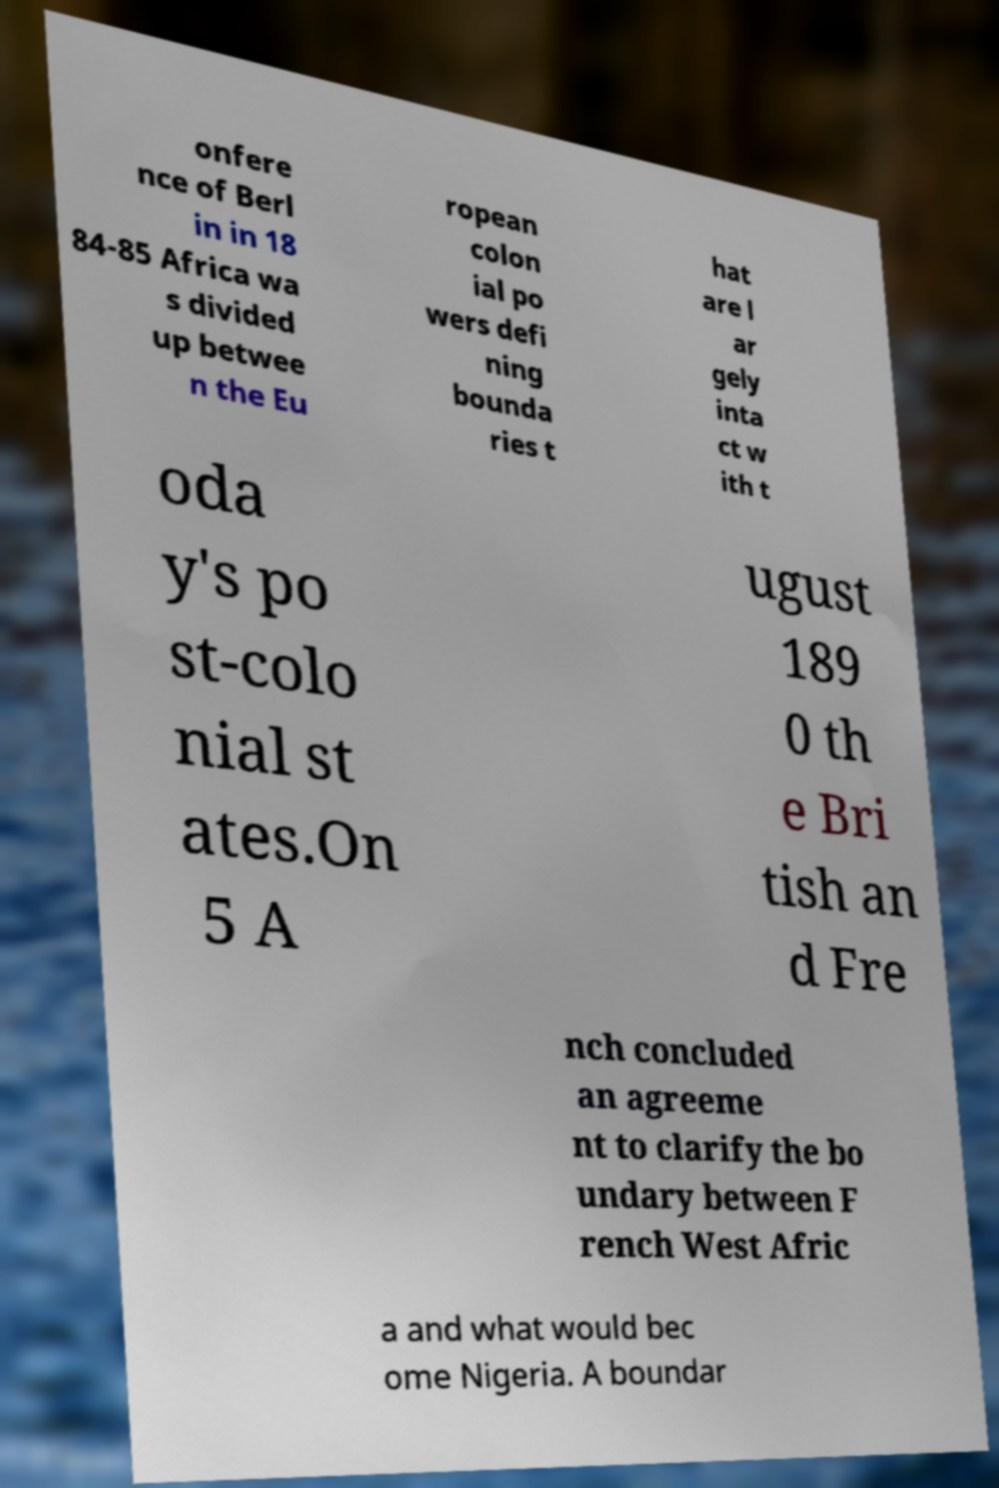Could you extract and type out the text from this image? onfere nce of Berl in in 18 84-85 Africa wa s divided up betwee n the Eu ropean colon ial po wers defi ning bounda ries t hat are l ar gely inta ct w ith t oda y's po st-colo nial st ates.On 5 A ugust 189 0 th e Bri tish an d Fre nch concluded an agreeme nt to clarify the bo undary between F rench West Afric a and what would bec ome Nigeria. A boundar 